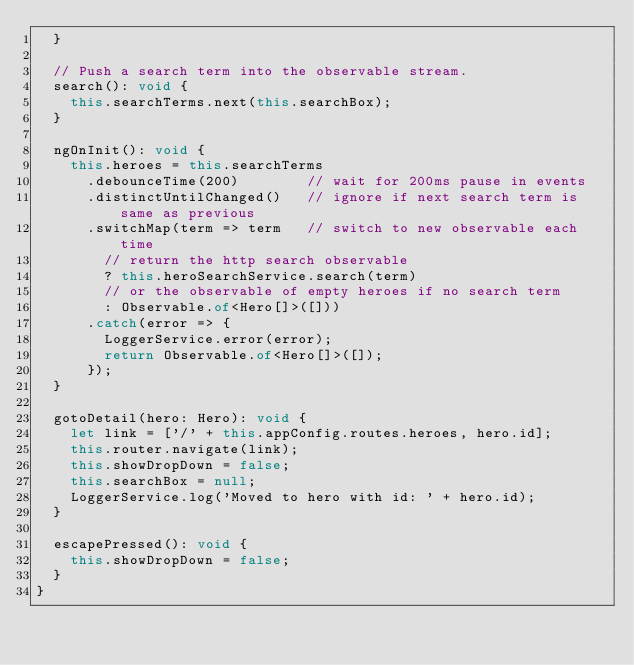Convert code to text. <code><loc_0><loc_0><loc_500><loc_500><_TypeScript_>  }

  // Push a search term into the observable stream.
  search(): void {
    this.searchTerms.next(this.searchBox);
  }

  ngOnInit(): void {
    this.heroes = this.searchTerms
      .debounceTime(200)        // wait for 200ms pause in events
      .distinctUntilChanged()   // ignore if next search term is same as previous
      .switchMap(term => term   // switch to new observable each time
        // return the http search observable
        ? this.heroSearchService.search(term)
        // or the observable of empty heroes if no search term
        : Observable.of<Hero[]>([]))
      .catch(error => {
        LoggerService.error(error);
        return Observable.of<Hero[]>([]);
      });
  }

  gotoDetail(hero: Hero): void {
    let link = ['/' + this.appConfig.routes.heroes, hero.id];
    this.router.navigate(link);
    this.showDropDown = false;
    this.searchBox = null;
    LoggerService.log('Moved to hero with id: ' + hero.id);
  }

  escapePressed(): void {
    this.showDropDown = false;
  }
}
</code> 